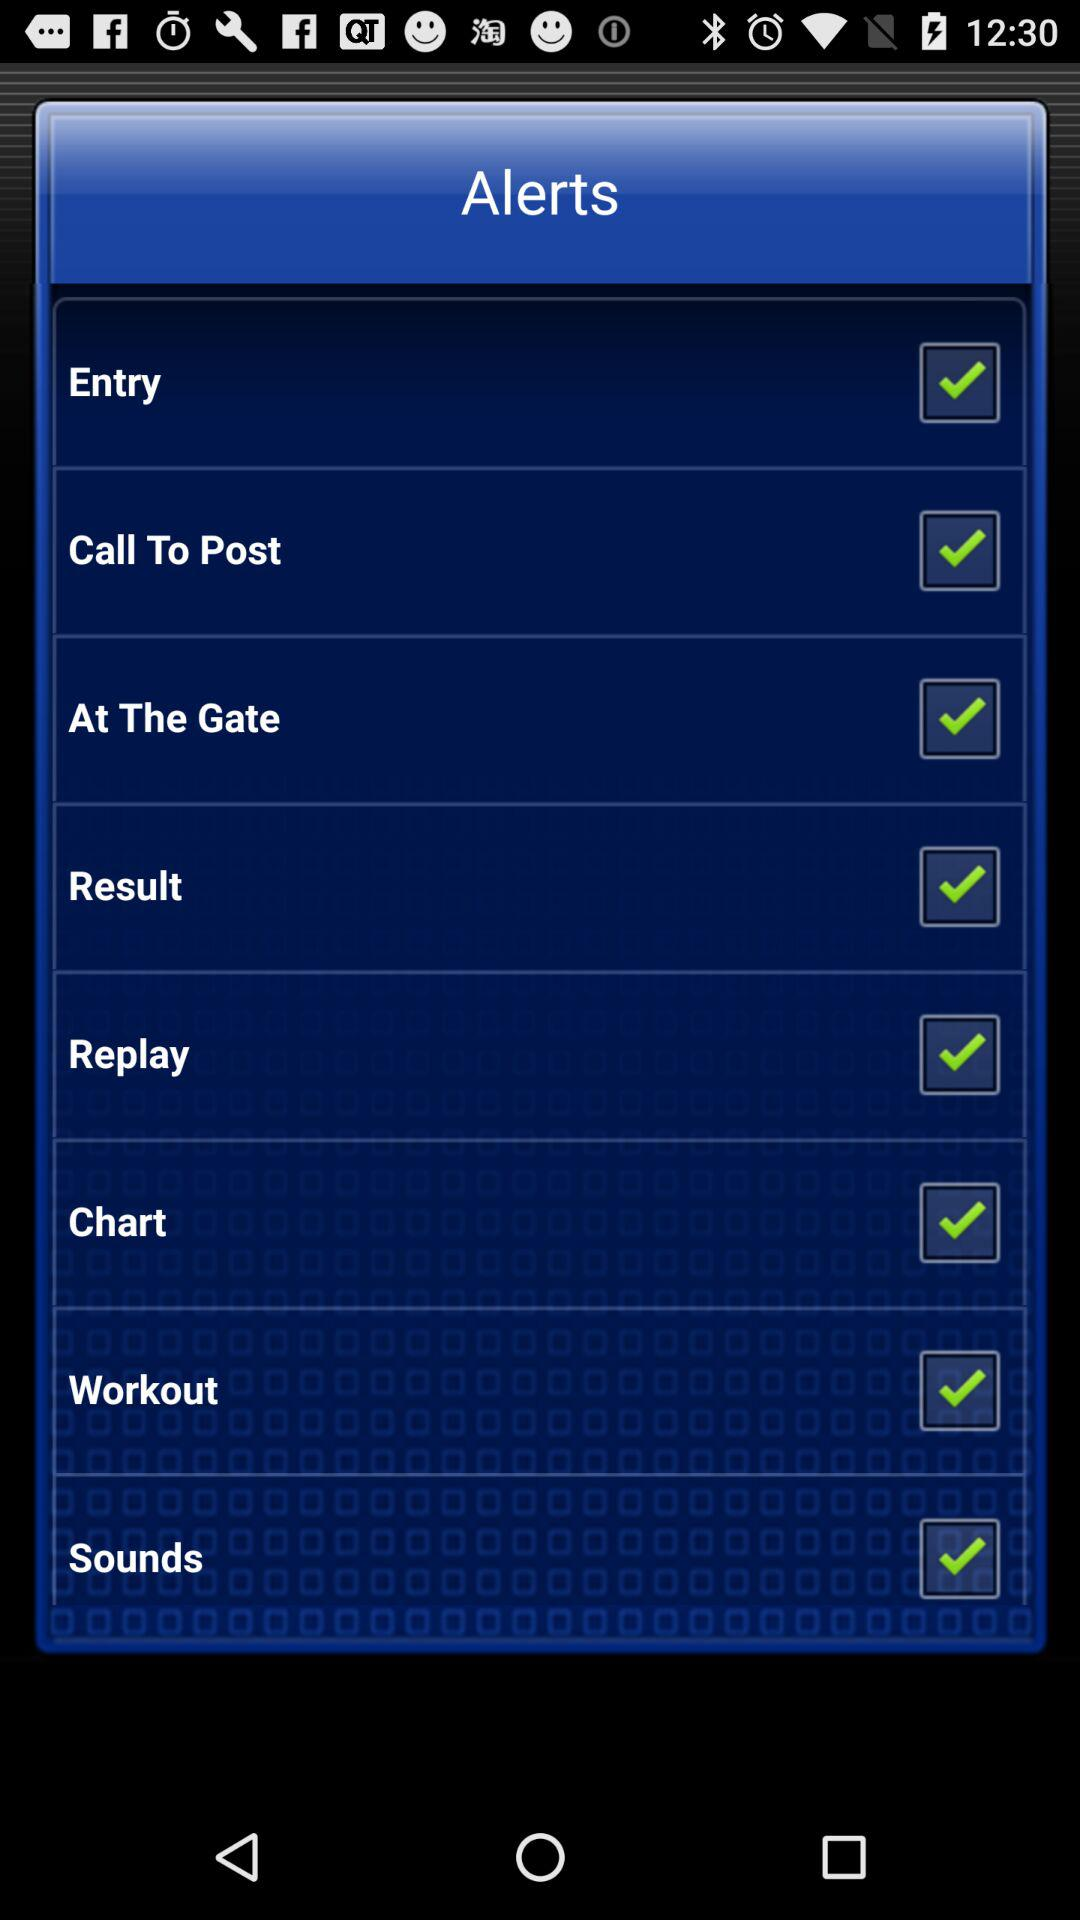What is the status of the "Entry"? The status of the "Entry" is "on". 